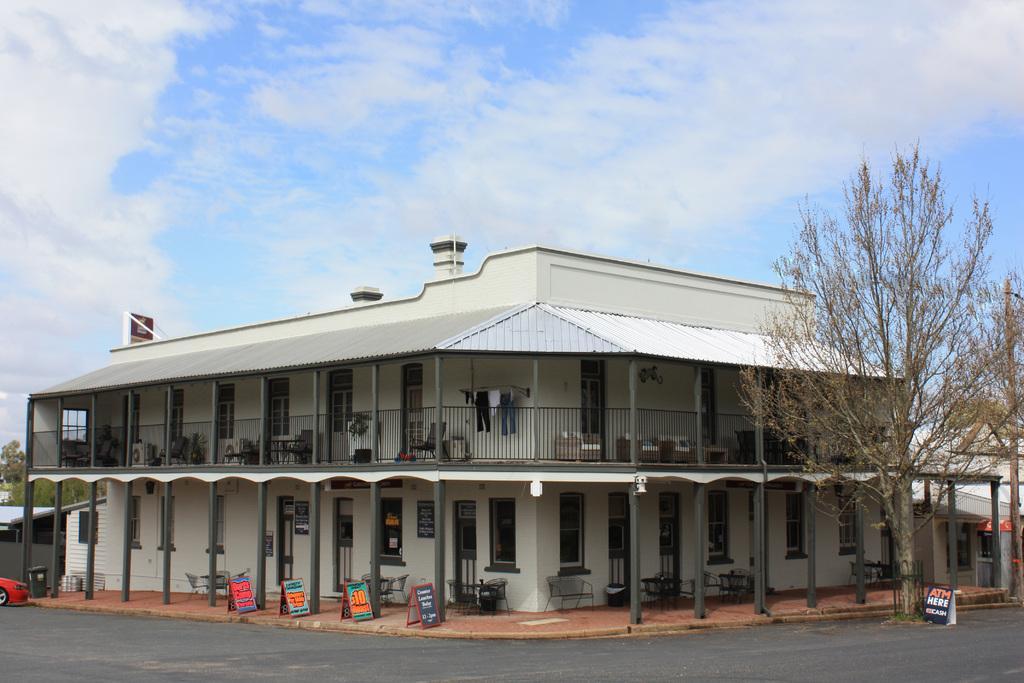Describe this image in one or two sentences. In this image we can see a building and few houses. There are many chairs in the image. We can see the clouds in the sky. There is a vehicle at the left side of the image. There is a road at the bottom of the image. There are few trees at the right side of the image. There are few trees at the left side of the image. There are few advertising boards in the image. 